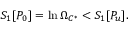<formula> <loc_0><loc_0><loc_500><loc_500>S _ { 1 } [ P _ { 0 } ] = \ln \Omega _ { C ^ { * } } < S _ { 1 } [ P _ { u } ] .</formula> 